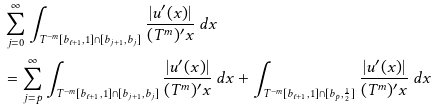Convert formula to latex. <formula><loc_0><loc_0><loc_500><loc_500>& \sum _ { j = 0 } ^ { \infty } \int _ { T ^ { - m } [ b _ { \ell + 1 } , 1 ] \cap [ b _ { j + 1 } , b _ { j } ] } \frac { | u ^ { \prime } ( x ) | } { ( T ^ { m } ) ^ { \prime } x } \, d x \\ & = \sum _ { j = p } ^ { \infty } \int _ { T ^ { - m } [ b _ { \ell + 1 } , 1 ] \cap [ b _ { j + 1 } , b _ { j } ] } \frac { | u ^ { \prime } ( x ) | } { ( T ^ { m } ) ^ { \prime } x } \, d x + \int _ { T ^ { - m } [ b _ { \ell + 1 } , 1 ] \cap [ b _ { p } , \frac { 1 } { 2 } ] } \frac { | u ^ { \prime } ( x ) | } { ( T ^ { m } ) ^ { \prime } x } \, d x</formula> 